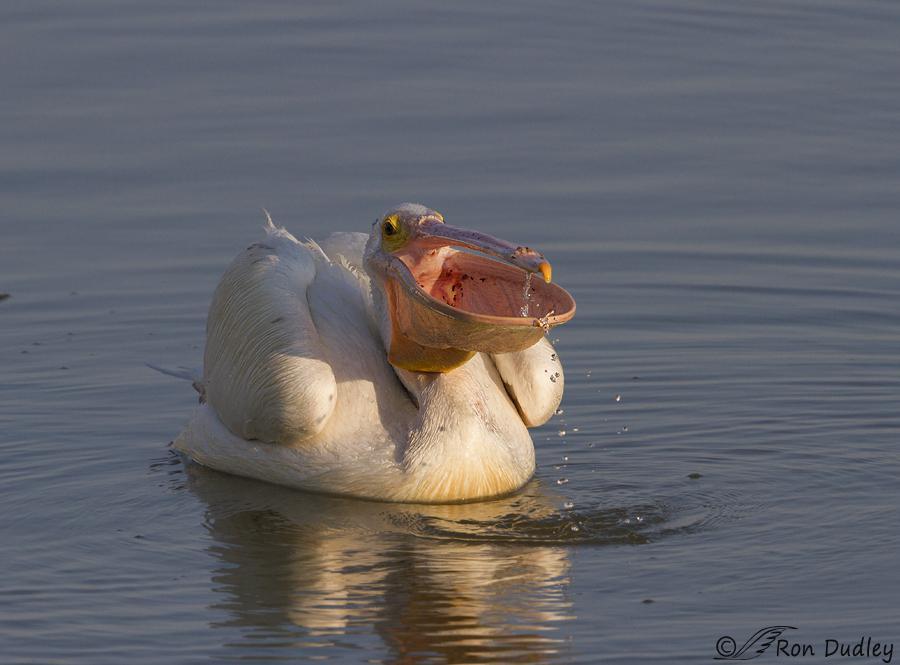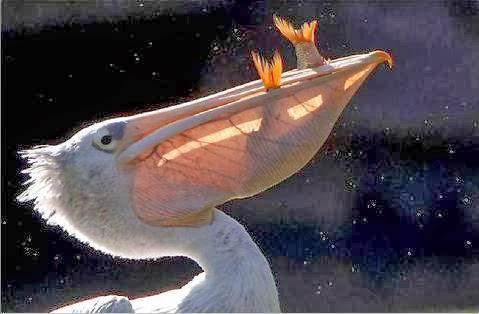The first image is the image on the left, the second image is the image on the right. Examine the images to the left and right. Is the description "At least two fishes are in a bird's mouth." accurate? Answer yes or no. Yes. The first image is the image on the left, the second image is the image on the right. Considering the images on both sides, is "Right image shows a dark gray bird with a sac-like expanded lower bill." valid? Answer yes or no. No. 